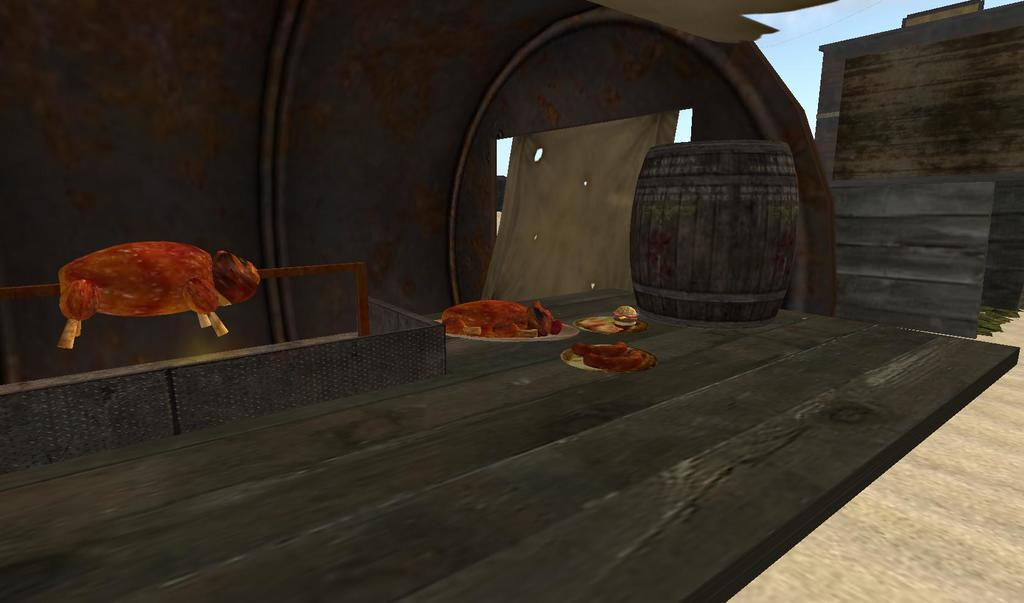What is on the plates that are visible in the image? A: There are plates with food in the image. What colors can be seen in the food? The food has red, brown, and cream colors. What type of container is present in the image? There is a wooden box in the image. What type of path is visible in the image? There is a wooden path in the image. What is the color of the sky in the image? The sky is blue in the image. How does the growth of the plants affect the act of expansion in the image? There are no plants present in the image, so the growth of plants and the act of expansion cannot be observed or discussed in relation to the image. 